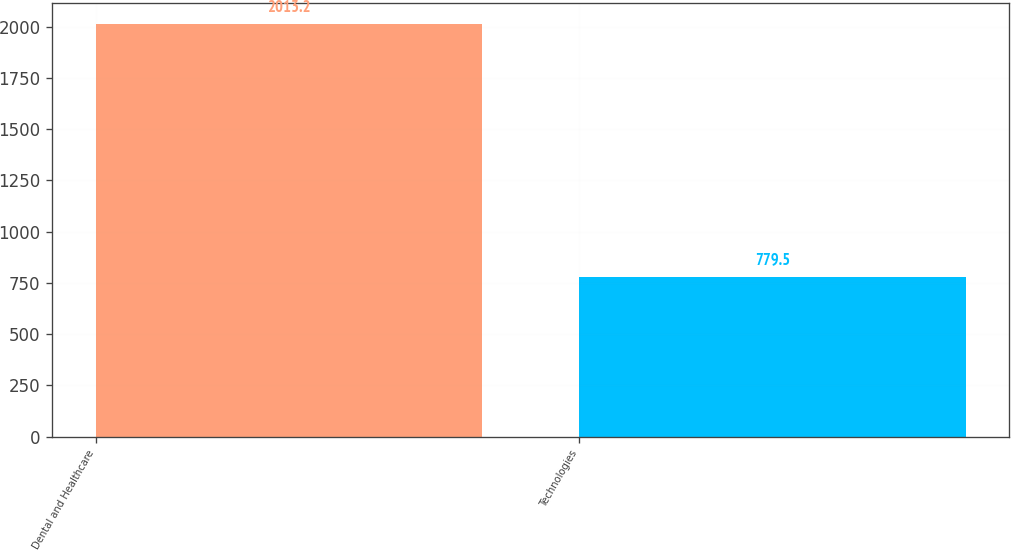<chart> <loc_0><loc_0><loc_500><loc_500><bar_chart><fcel>Dental and Healthcare<fcel>Technologies<nl><fcel>2013.2<fcel>779.5<nl></chart> 